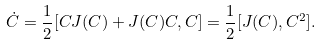<formula> <loc_0><loc_0><loc_500><loc_500>\dot { C } = \frac { 1 } { 2 } [ C J ( C ) + J ( C ) C , C ] = \frac { 1 } { 2 } [ J ( C ) , C ^ { 2 } ] .</formula> 